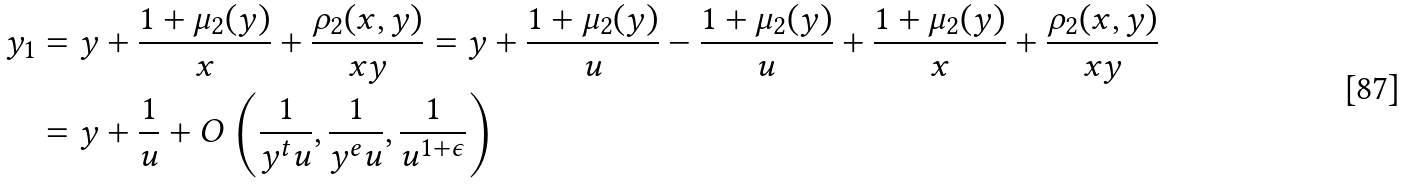Convert formula to latex. <formula><loc_0><loc_0><loc_500><loc_500>y _ { 1 } & = y + \frac { 1 + \mu _ { 2 } ( y ) } { x } + \frac { \rho _ { 2 } ( x , y ) } { x y } = y + \frac { 1 + \mu _ { 2 } ( y ) } { u } - \frac { 1 + \mu _ { 2 } ( y ) } { u } + \frac { 1 + \mu _ { 2 } ( y ) } { x } + \frac { \rho _ { 2 } ( x , y ) } { x y } \\ & = y + \frac { 1 } { u } + O \left ( \frac { 1 } { y ^ { t } u } , \frac { 1 } { y ^ { e } u } , \frac { 1 } { u ^ { 1 + \epsilon } } \right )</formula> 